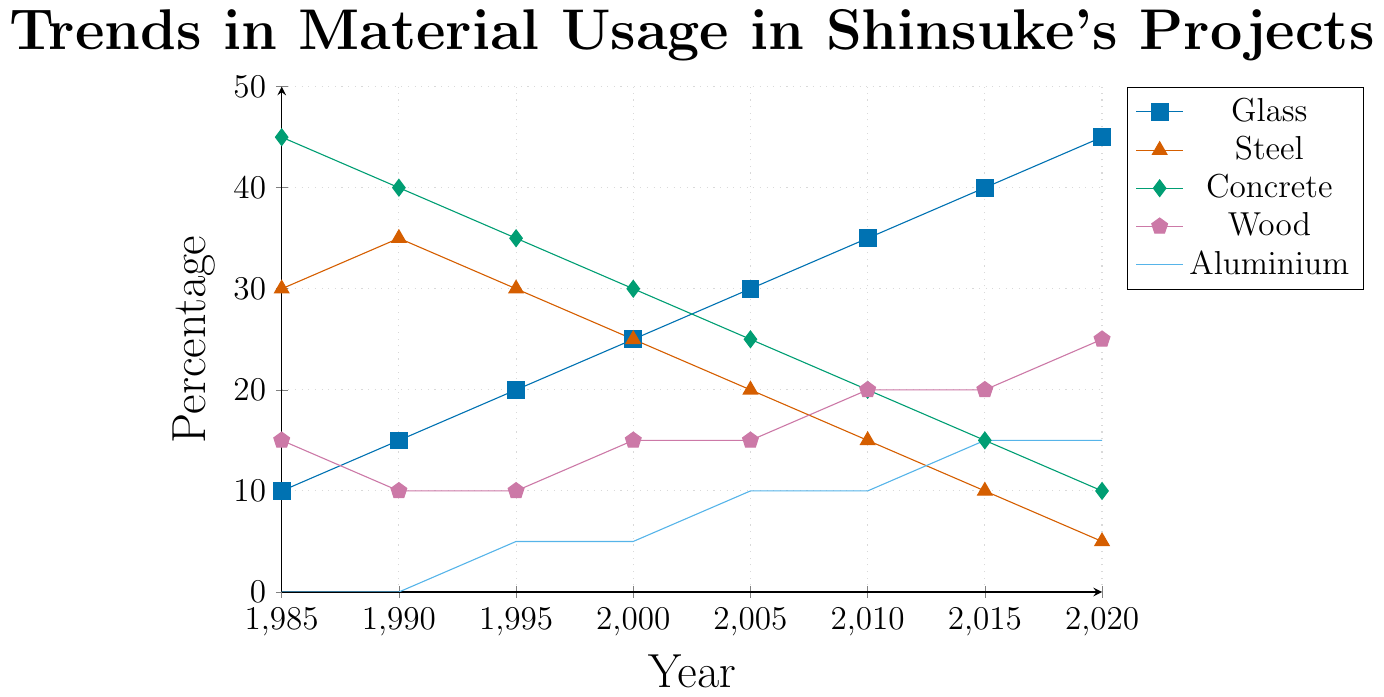what is the material with the highest usage in 1985? The figure shows the percentage usage of different materials over the years. For 1985, compare the heights of all lines at that point. The highest line corresponds to concrete at 45%.
Answer: concrete how has the usage of steel changed from 1985 to 2020? The figure shows the percentage of steel usage decreasing over the years. In 1985, it starts at 30% and gradually decreases to 5% in 2020.
Answer: decreased what is the pattern in the usage of glass over the years? Analyzing the line for glass from 1985 to 2020, it shows a steady increase from 10% in 1985 to 45% in 2020, indicating a continuous rise.
Answer: continuous rise which material was used more in 2000, wood or steel? Locate the values for wood and steel in the year 2000. Wood is at 15% while steel is at 25%. Steel was used more.
Answer: steel in which year did the usage of aluminium start appearing in shinsuke's projects? The figure shows aluminium usage starting in 1995, as it is at 0% before that year.
Answer: 1995 what is the sum of the usage percentages of all materials in 2010? Add the values for all materials in 2010: glass (35%) + steel (15%) + concrete (20%) + wood (20%) + aluminium (10%) = 100%.
Answer: 100% which material shows the greatest decrease in usage from 1985 to 2020? Compare the beginning and ending percentages of each material. Steel decreases from 30% to 5%, a decrease of 25 points, which is the greatest decrease.
Answer: steel between which years did glass usage surpass concrete usage for the first time? Compare the trends of glass and concrete lines. The lines intersect between 2010 and 2015, indicating the first time glass surpassed concrete usage.
Answer: 2010 and 2015 what is the average usage of wood over the given years? Sum the percentages of wood from all the years and divide by the number of years: (15 + 10 + 10 + 15 + 15 + 20 + 20 + 25) / 8 = 17.5%.
Answer: 17.5% was there any material that consistently increased in usage every recorded year? Review the trend lines. Glass consistently increases from 1985 to 2020 without any decreases.
Answer: glass 